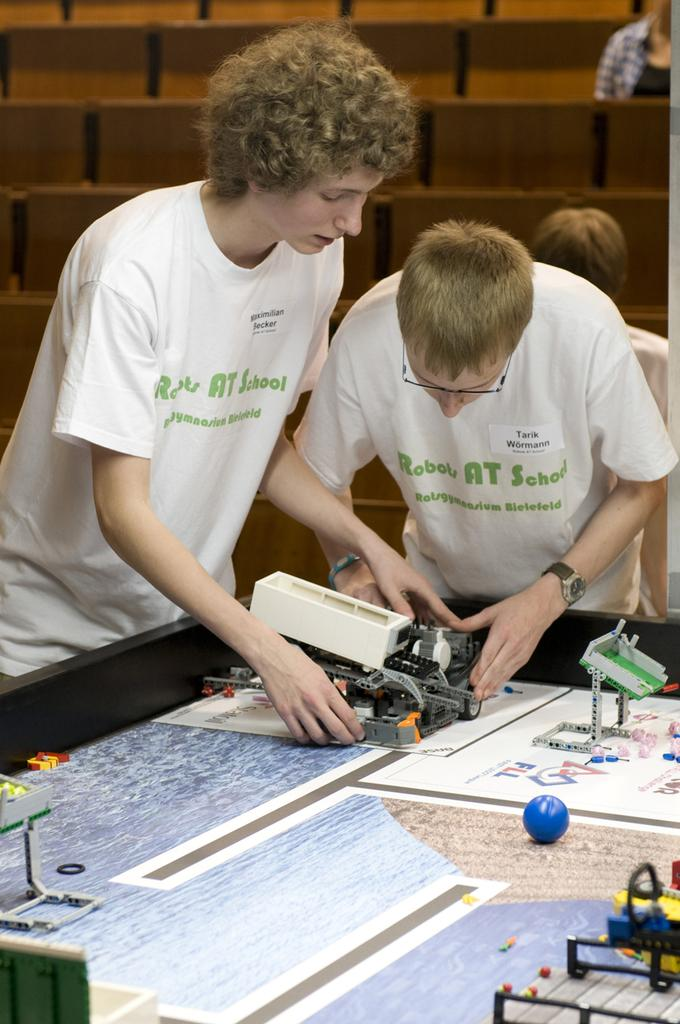How many people are present in the image? There are two persons in the image. What is located in the image besides the people? There is a table in the image. What is on the table? There is a ball and other objects on the table. What can be seen in the background of the image? There are chairs and two more persons in the background of the image. What type of sugar is being used to sweeten the goldfish in the image? There is no sugar or goldfish present in the image. What color is the beam that supports the table in the image? There is no beam visible in the image; it only shows a table, objects, and people. 